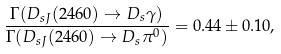Convert formula to latex. <formula><loc_0><loc_0><loc_500><loc_500>\frac { \Gamma ( D _ { s J } ( 2 4 6 0 ) \to D _ { s } \gamma ) } { \Gamma ( D _ { s J } ( 2 4 6 0 ) \to D _ { s } \pi ^ { 0 } ) } = 0 . 4 4 \pm 0 . 1 0 ,</formula> 